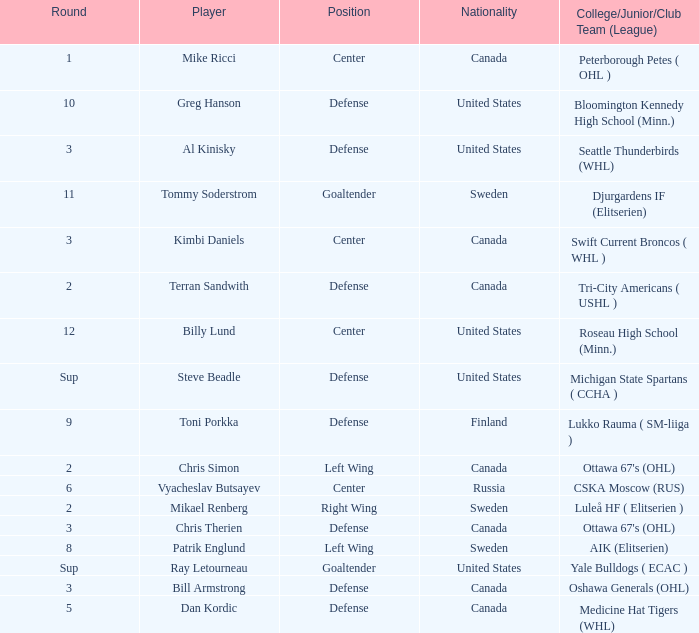What is the school that hosts mikael renberg Luleå HF ( Elitserien ). 